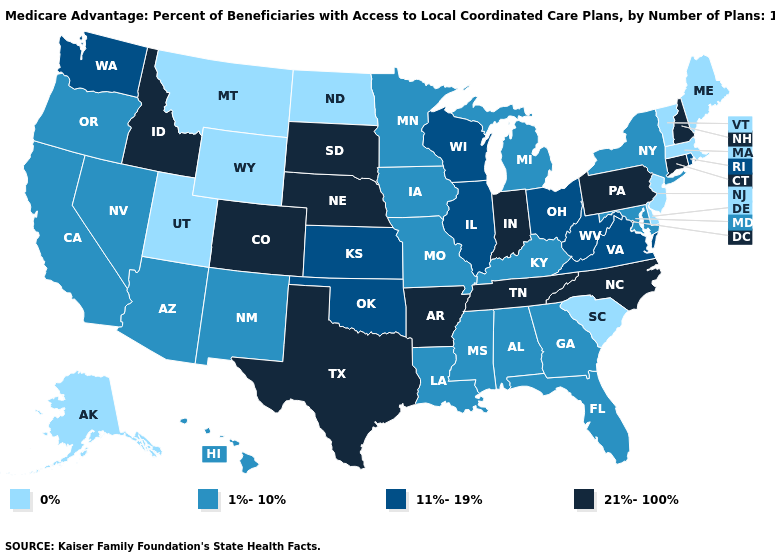Does Massachusetts have the lowest value in the USA?
Short answer required. Yes. Does Kentucky have a higher value than Maine?
Concise answer only. Yes. What is the value of Illinois?
Quick response, please. 11%-19%. Does Indiana have the highest value in the USA?
Concise answer only. Yes. What is the lowest value in states that border Vermont?
Write a very short answer. 0%. What is the value of North Dakota?
Answer briefly. 0%. Which states hav the highest value in the West?
Short answer required. Colorado, Idaho. Name the states that have a value in the range 11%-19%?
Concise answer only. Illinois, Kansas, Ohio, Oklahoma, Rhode Island, Virginia, Washington, Wisconsin, West Virginia. Name the states that have a value in the range 0%?
Give a very brief answer. Alaska, Delaware, Massachusetts, Maine, Montana, North Dakota, New Jersey, South Carolina, Utah, Vermont, Wyoming. Name the states that have a value in the range 11%-19%?
Give a very brief answer. Illinois, Kansas, Ohio, Oklahoma, Rhode Island, Virginia, Washington, Wisconsin, West Virginia. What is the highest value in the MidWest ?
Be succinct. 21%-100%. Does the map have missing data?
Answer briefly. No. Does New Hampshire have the highest value in the USA?
Give a very brief answer. Yes. What is the highest value in the MidWest ?
Give a very brief answer. 21%-100%. What is the value of Arizona?
Short answer required. 1%-10%. 